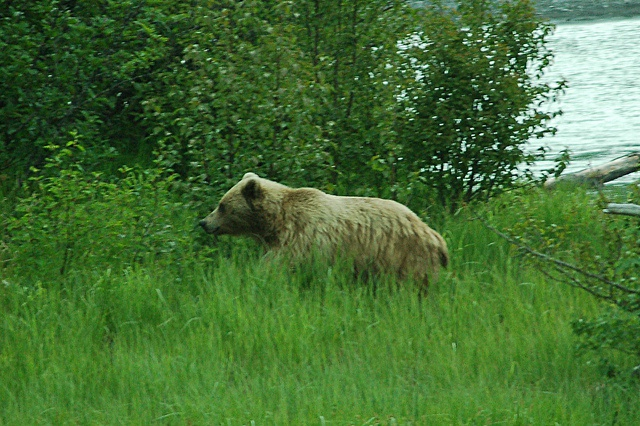Describe the objects in this image and their specific colors. I can see a bear in darkgreen, black, and olive tones in this image. 